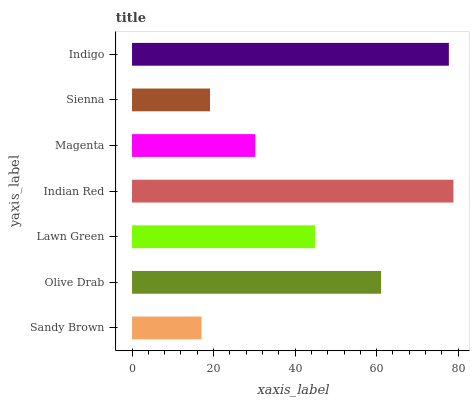Is Sandy Brown the minimum?
Answer yes or no. Yes. Is Indian Red the maximum?
Answer yes or no. Yes. Is Olive Drab the minimum?
Answer yes or no. No. Is Olive Drab the maximum?
Answer yes or no. No. Is Olive Drab greater than Sandy Brown?
Answer yes or no. Yes. Is Sandy Brown less than Olive Drab?
Answer yes or no. Yes. Is Sandy Brown greater than Olive Drab?
Answer yes or no. No. Is Olive Drab less than Sandy Brown?
Answer yes or no. No. Is Lawn Green the high median?
Answer yes or no. Yes. Is Lawn Green the low median?
Answer yes or no. Yes. Is Magenta the high median?
Answer yes or no. No. Is Sienna the low median?
Answer yes or no. No. 